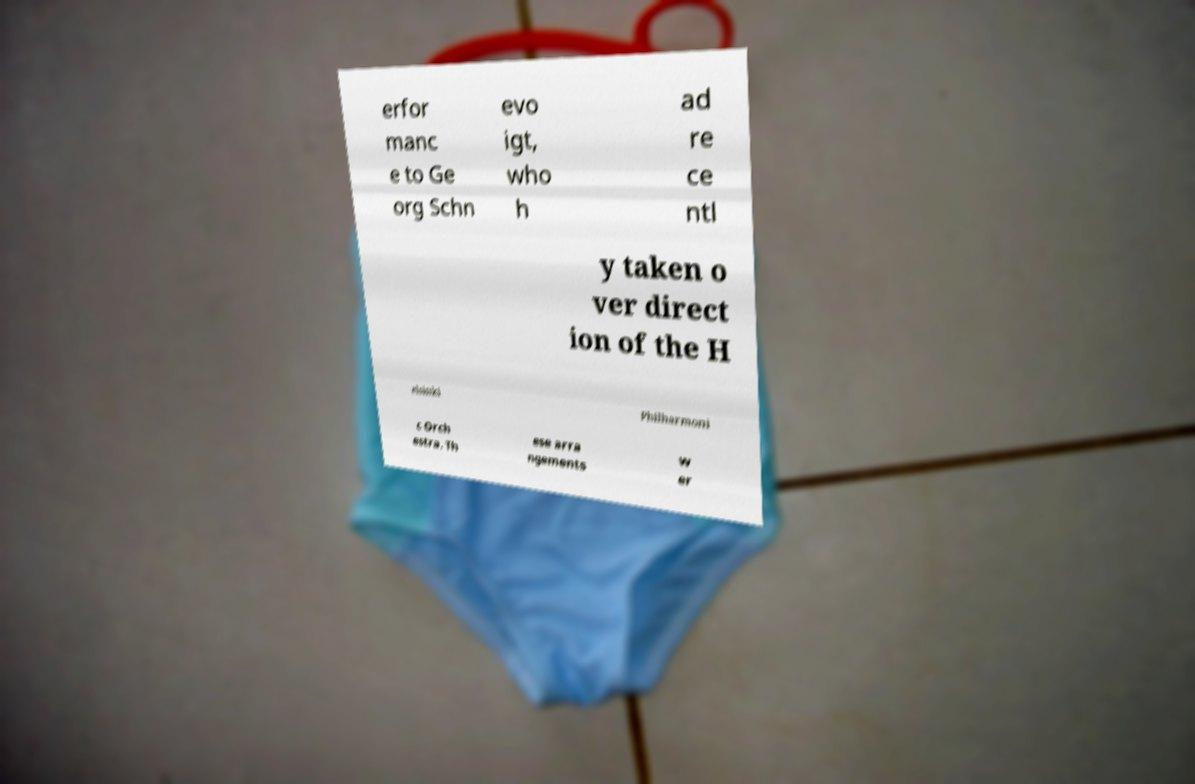There's text embedded in this image that I need extracted. Can you transcribe it verbatim? erfor manc e to Ge org Schn evo igt, who h ad re ce ntl y taken o ver direct ion of the H elsinki Philharmoni c Orch estra. Th ese arra ngements w er 